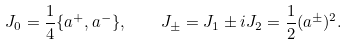Convert formula to latex. <formula><loc_0><loc_0><loc_500><loc_500>J _ { 0 } = \frac { 1 } { 4 } \{ a ^ { + } , a ^ { - } \} , \quad J _ { \pm } = J _ { 1 } \pm i J _ { 2 } = \frac { 1 } { 2 } ( a ^ { \pm } ) ^ { 2 } .</formula> 